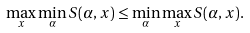<formula> <loc_0><loc_0><loc_500><loc_500>\max _ { x } \min _ { \alpha } S ( \alpha , x ) \leq \min _ { \alpha } \max _ { x } S ( \alpha , x ) .</formula> 